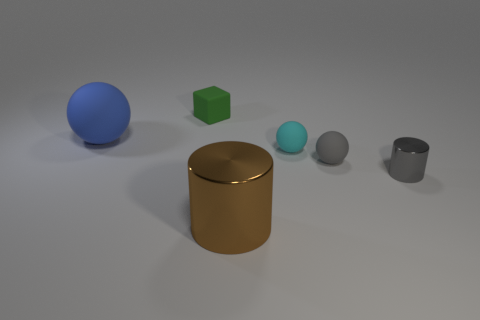Subtract all gray spheres. How many spheres are left? 2 Subtract all large rubber balls. How many balls are left? 2 Subtract 1 gray balls. How many objects are left? 5 Subtract all cylinders. How many objects are left? 4 Subtract 2 cylinders. How many cylinders are left? 0 Subtract all blue cylinders. Subtract all purple blocks. How many cylinders are left? 2 Subtract all blue cylinders. How many gray spheres are left? 1 Subtract all tiny purple rubber balls. Subtract all gray shiny cylinders. How many objects are left? 5 Add 2 cyan spheres. How many cyan spheres are left? 3 Add 2 large brown things. How many large brown things exist? 3 